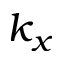Convert formula to latex. <formula><loc_0><loc_0><loc_500><loc_500>k _ { x }</formula> 